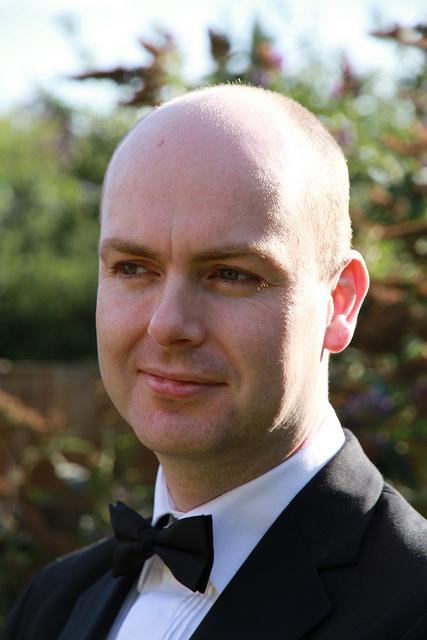Does this man have to take precautions when eating ice cream?
Keep it brief. No. What is this man dressed up for?
Quick response, please. Wedding. What color is the tie?
Be succinct. Black. Is this man bald?
Quick response, please. Yes. Is this man wearing glasses?
Short answer required. No. 